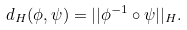Convert formula to latex. <formula><loc_0><loc_0><loc_500><loc_500>d _ { H } ( \phi , \psi ) = | | \phi ^ { - 1 } \circ \psi | | _ { H } .</formula> 